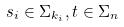Convert formula to latex. <formula><loc_0><loc_0><loc_500><loc_500>s _ { i } \in \Sigma _ { k _ { i } } , t \in \Sigma _ { n }</formula> 